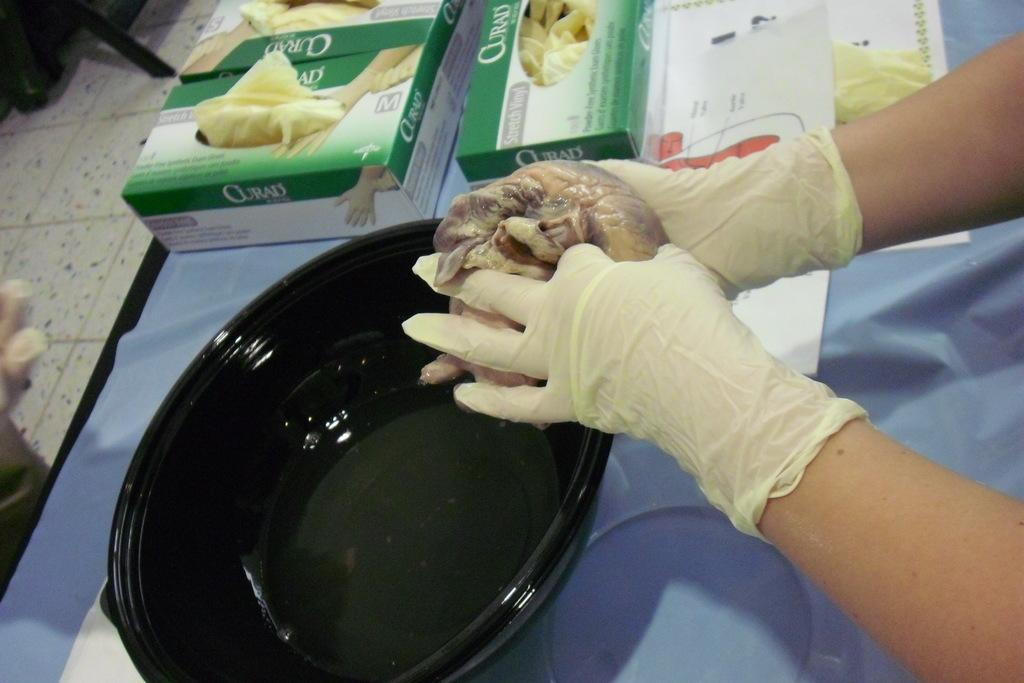What objects are present in the image? There are boxes, papers, a bowl, and cloth in the image. What is the person in the image doing? The person is holding meat and wearing gloves. What is the person's hands touching? The person's hands are touching meat. What is the person wearing on their hands? The person's hands are wearing gloves. What is on the floor in the background of the image? There is an object on the floor in the background of the image. What type of cherries can be seen in the market in the image? There is no market or cherries present in the image. Is the person in the image exploring a cave while holding the meat? There is no cave present in the image; the person is in a different setting. 